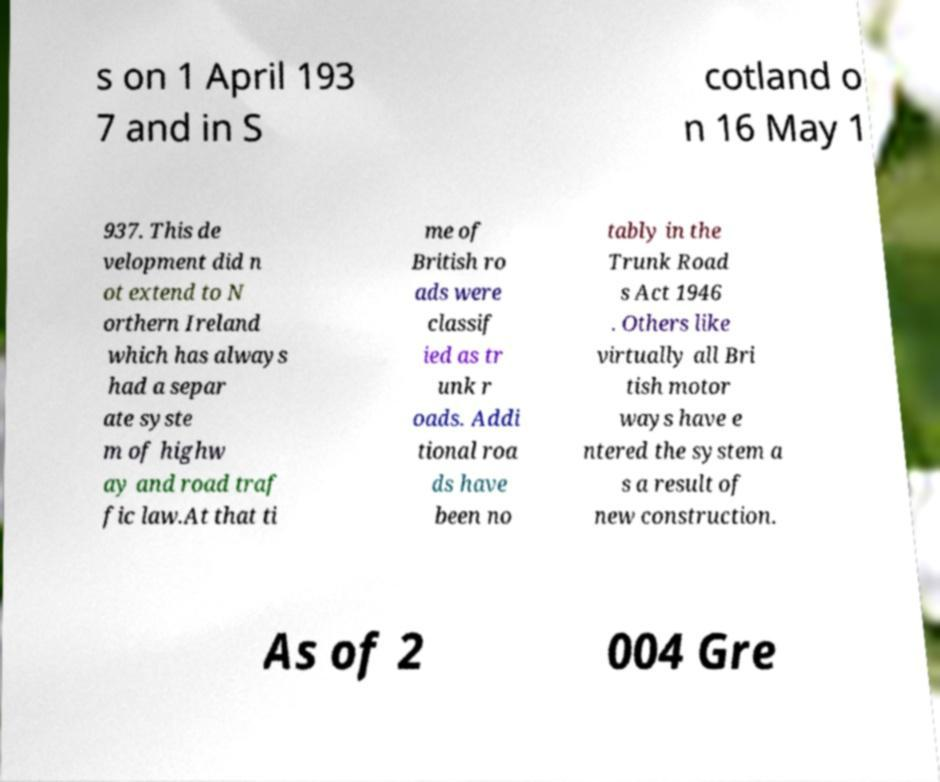What messages or text are displayed in this image? I need them in a readable, typed format. s on 1 April 193 7 and in S cotland o n 16 May 1 937. This de velopment did n ot extend to N orthern Ireland which has always had a separ ate syste m of highw ay and road traf fic law.At that ti me of British ro ads were classif ied as tr unk r oads. Addi tional roa ds have been no tably in the Trunk Road s Act 1946 . Others like virtually all Bri tish motor ways have e ntered the system a s a result of new construction. As of 2 004 Gre 